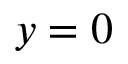Convert formula to latex. <formula><loc_0><loc_0><loc_500><loc_500>y = 0</formula> 